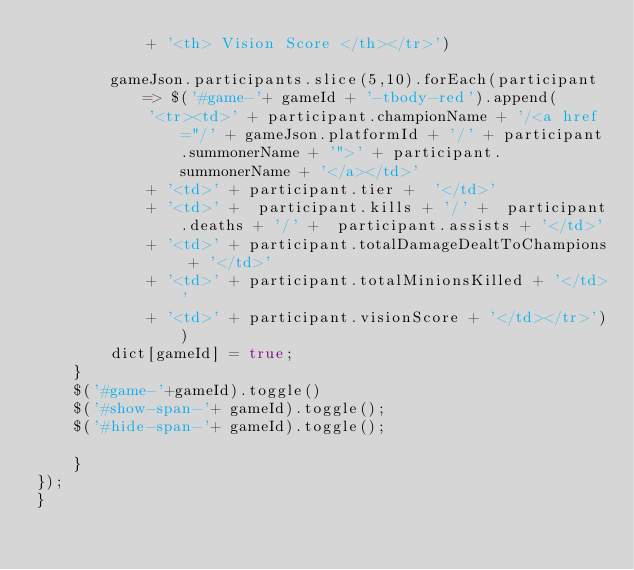<code> <loc_0><loc_0><loc_500><loc_500><_JavaScript_>            + '<th> Vision Score </th></tr>')

        gameJson.participants.slice(5,10).forEach(participant => $('#game-'+ gameId + '-tbody-red').append(
            '<tr><td>' + participant.championName + '/<a href="/' + gameJson.platformId + '/' + participant.summonerName + '">' + participant.summonerName + '</a></td>'
            + '<td>' + participant.tier +  '</td>'
            + '<td>' +  participant.kills + '/' +  participant.deaths + '/' +  participant.assists + '</td>'
            + '<td>' + participant.totalDamageDealtToChampions + '</td>'
            + '<td>' + participant.totalMinionsKilled + '</td>'
            + '<td>' + participant.visionScore + '</td></tr>'))
        dict[gameId] = true;
    }
    $('#game-'+gameId).toggle()
    $('#show-span-'+ gameId).toggle();
    $('#hide-span-'+ gameId).toggle();
        
    }
});
}</code> 